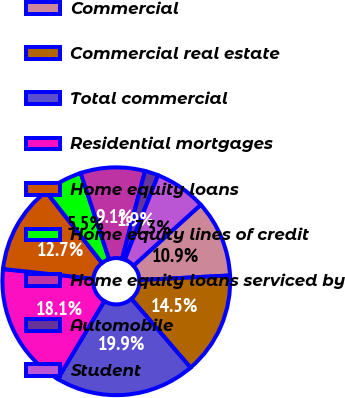<chart> <loc_0><loc_0><loc_500><loc_500><pie_chart><fcel>Commercial<fcel>Commercial real estate<fcel>Total commercial<fcel>Residential mortgages<fcel>Home equity loans<fcel>Home equity lines of credit<fcel>Home equity loans serviced by<fcel>Automobile<fcel>Student<nl><fcel>10.91%<fcel>14.51%<fcel>19.9%<fcel>18.11%<fcel>12.71%<fcel>5.52%<fcel>9.11%<fcel>1.92%<fcel>7.31%<nl></chart> 